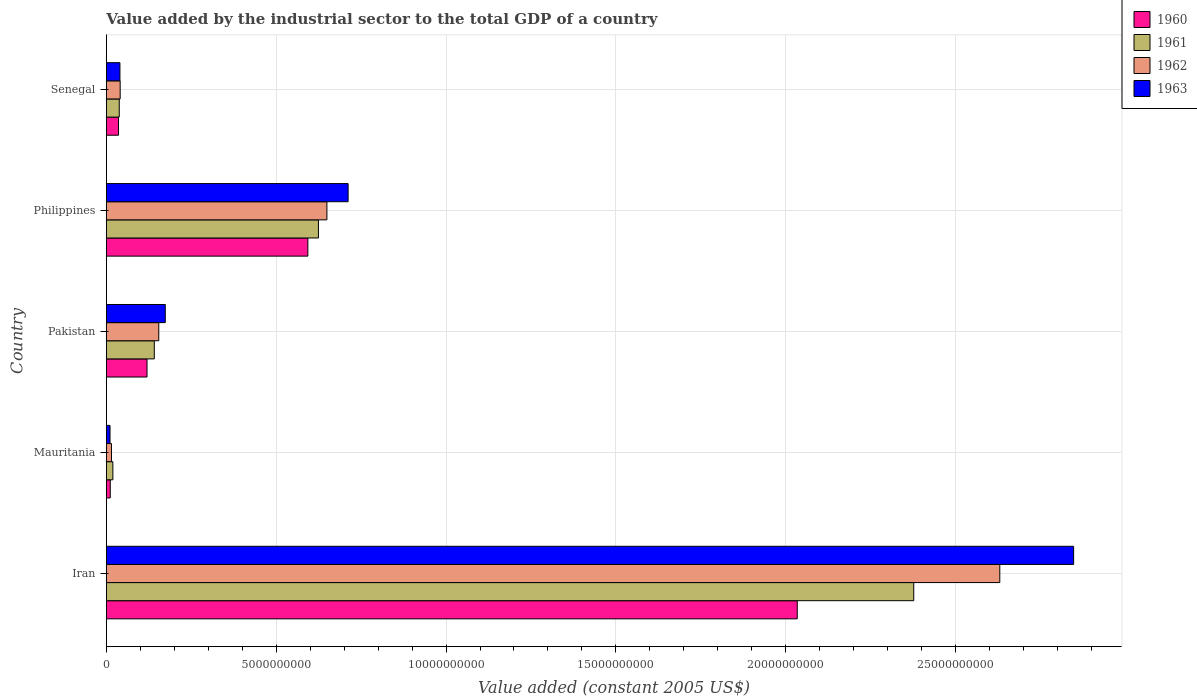How many different coloured bars are there?
Ensure brevity in your answer.  4. How many groups of bars are there?
Provide a succinct answer. 5. How many bars are there on the 1st tick from the top?
Keep it short and to the point. 4. What is the label of the 1st group of bars from the top?
Make the answer very short. Senegal. In how many cases, is the number of bars for a given country not equal to the number of legend labels?
Give a very brief answer. 0. What is the value added by the industrial sector in 1962 in Philippines?
Give a very brief answer. 6.49e+09. Across all countries, what is the maximum value added by the industrial sector in 1961?
Your answer should be compact. 2.38e+1. Across all countries, what is the minimum value added by the industrial sector in 1961?
Ensure brevity in your answer.  1.92e+08. In which country was the value added by the industrial sector in 1962 maximum?
Your answer should be very brief. Iran. In which country was the value added by the industrial sector in 1963 minimum?
Keep it short and to the point. Mauritania. What is the total value added by the industrial sector in 1961 in the graph?
Ensure brevity in your answer.  3.20e+1. What is the difference between the value added by the industrial sector in 1960 in Pakistan and that in Philippines?
Provide a succinct answer. -4.73e+09. What is the difference between the value added by the industrial sector in 1961 in Mauritania and the value added by the industrial sector in 1960 in Senegal?
Make the answer very short. -1.66e+08. What is the average value added by the industrial sector in 1963 per country?
Your answer should be compact. 7.57e+09. What is the difference between the value added by the industrial sector in 1963 and value added by the industrial sector in 1960 in Iran?
Provide a short and direct response. 8.14e+09. What is the ratio of the value added by the industrial sector in 1962 in Iran to that in Philippines?
Make the answer very short. 4.05. What is the difference between the highest and the second highest value added by the industrial sector in 1963?
Offer a terse response. 2.14e+1. What is the difference between the highest and the lowest value added by the industrial sector in 1963?
Provide a short and direct response. 2.84e+1. In how many countries, is the value added by the industrial sector in 1963 greater than the average value added by the industrial sector in 1963 taken over all countries?
Provide a succinct answer. 1. Is the sum of the value added by the industrial sector in 1961 in Pakistan and Senegal greater than the maximum value added by the industrial sector in 1962 across all countries?
Your response must be concise. No. Is it the case that in every country, the sum of the value added by the industrial sector in 1962 and value added by the industrial sector in 1960 is greater than the sum of value added by the industrial sector in 1961 and value added by the industrial sector in 1963?
Offer a terse response. No. Is it the case that in every country, the sum of the value added by the industrial sector in 1963 and value added by the industrial sector in 1962 is greater than the value added by the industrial sector in 1960?
Make the answer very short. Yes. Are all the bars in the graph horizontal?
Keep it short and to the point. Yes. How many countries are there in the graph?
Provide a succinct answer. 5. What is the difference between two consecutive major ticks on the X-axis?
Keep it short and to the point. 5.00e+09. Are the values on the major ticks of X-axis written in scientific E-notation?
Make the answer very short. No. Does the graph contain any zero values?
Ensure brevity in your answer.  No. What is the title of the graph?
Your answer should be compact. Value added by the industrial sector to the total GDP of a country. What is the label or title of the X-axis?
Provide a succinct answer. Value added (constant 2005 US$). What is the Value added (constant 2005 US$) of 1960 in Iran?
Your response must be concise. 2.03e+1. What is the Value added (constant 2005 US$) of 1961 in Iran?
Offer a terse response. 2.38e+1. What is the Value added (constant 2005 US$) in 1962 in Iran?
Your answer should be very brief. 2.63e+1. What is the Value added (constant 2005 US$) of 1963 in Iran?
Offer a terse response. 2.85e+1. What is the Value added (constant 2005 US$) in 1960 in Mauritania?
Your answer should be very brief. 1.15e+08. What is the Value added (constant 2005 US$) in 1961 in Mauritania?
Keep it short and to the point. 1.92e+08. What is the Value added (constant 2005 US$) in 1962 in Mauritania?
Offer a terse response. 1.51e+08. What is the Value added (constant 2005 US$) in 1963 in Mauritania?
Offer a terse response. 1.08e+08. What is the Value added (constant 2005 US$) in 1960 in Pakistan?
Ensure brevity in your answer.  1.20e+09. What is the Value added (constant 2005 US$) of 1961 in Pakistan?
Your answer should be very brief. 1.41e+09. What is the Value added (constant 2005 US$) in 1962 in Pakistan?
Offer a very short reply. 1.54e+09. What is the Value added (constant 2005 US$) of 1963 in Pakistan?
Your answer should be compact. 1.74e+09. What is the Value added (constant 2005 US$) of 1960 in Philippines?
Offer a very short reply. 5.93e+09. What is the Value added (constant 2005 US$) in 1961 in Philippines?
Offer a terse response. 6.24e+09. What is the Value added (constant 2005 US$) of 1962 in Philippines?
Ensure brevity in your answer.  6.49e+09. What is the Value added (constant 2005 US$) of 1963 in Philippines?
Offer a very short reply. 7.12e+09. What is the Value added (constant 2005 US$) of 1960 in Senegal?
Ensure brevity in your answer.  3.58e+08. What is the Value added (constant 2005 US$) in 1961 in Senegal?
Offer a terse response. 3.80e+08. What is the Value added (constant 2005 US$) in 1962 in Senegal?
Provide a short and direct response. 4.08e+08. What is the Value added (constant 2005 US$) in 1963 in Senegal?
Your response must be concise. 4.01e+08. Across all countries, what is the maximum Value added (constant 2005 US$) in 1960?
Provide a succinct answer. 2.03e+1. Across all countries, what is the maximum Value added (constant 2005 US$) of 1961?
Offer a terse response. 2.38e+1. Across all countries, what is the maximum Value added (constant 2005 US$) of 1962?
Provide a short and direct response. 2.63e+1. Across all countries, what is the maximum Value added (constant 2005 US$) in 1963?
Keep it short and to the point. 2.85e+1. Across all countries, what is the minimum Value added (constant 2005 US$) of 1960?
Make the answer very short. 1.15e+08. Across all countries, what is the minimum Value added (constant 2005 US$) in 1961?
Provide a short and direct response. 1.92e+08. Across all countries, what is the minimum Value added (constant 2005 US$) in 1962?
Your answer should be very brief. 1.51e+08. Across all countries, what is the minimum Value added (constant 2005 US$) of 1963?
Ensure brevity in your answer.  1.08e+08. What is the total Value added (constant 2005 US$) in 1960 in the graph?
Keep it short and to the point. 2.79e+1. What is the total Value added (constant 2005 US$) of 1961 in the graph?
Give a very brief answer. 3.20e+1. What is the total Value added (constant 2005 US$) in 1962 in the graph?
Offer a terse response. 3.49e+1. What is the total Value added (constant 2005 US$) in 1963 in the graph?
Provide a short and direct response. 3.78e+1. What is the difference between the Value added (constant 2005 US$) in 1960 in Iran and that in Mauritania?
Keep it short and to the point. 2.02e+1. What is the difference between the Value added (constant 2005 US$) in 1961 in Iran and that in Mauritania?
Provide a succinct answer. 2.36e+1. What is the difference between the Value added (constant 2005 US$) in 1962 in Iran and that in Mauritania?
Give a very brief answer. 2.62e+1. What is the difference between the Value added (constant 2005 US$) in 1963 in Iran and that in Mauritania?
Your answer should be compact. 2.84e+1. What is the difference between the Value added (constant 2005 US$) of 1960 in Iran and that in Pakistan?
Your answer should be very brief. 1.91e+1. What is the difference between the Value added (constant 2005 US$) in 1961 in Iran and that in Pakistan?
Offer a terse response. 2.24e+1. What is the difference between the Value added (constant 2005 US$) in 1962 in Iran and that in Pakistan?
Your answer should be very brief. 2.48e+1. What is the difference between the Value added (constant 2005 US$) of 1963 in Iran and that in Pakistan?
Provide a succinct answer. 2.67e+1. What is the difference between the Value added (constant 2005 US$) in 1960 in Iran and that in Philippines?
Keep it short and to the point. 1.44e+1. What is the difference between the Value added (constant 2005 US$) in 1961 in Iran and that in Philippines?
Your answer should be compact. 1.75e+1. What is the difference between the Value added (constant 2005 US$) in 1962 in Iran and that in Philippines?
Your answer should be compact. 1.98e+1. What is the difference between the Value added (constant 2005 US$) of 1963 in Iran and that in Philippines?
Provide a succinct answer. 2.14e+1. What is the difference between the Value added (constant 2005 US$) in 1960 in Iran and that in Senegal?
Offer a terse response. 2.00e+1. What is the difference between the Value added (constant 2005 US$) in 1961 in Iran and that in Senegal?
Offer a terse response. 2.34e+1. What is the difference between the Value added (constant 2005 US$) of 1962 in Iran and that in Senegal?
Your response must be concise. 2.59e+1. What is the difference between the Value added (constant 2005 US$) of 1963 in Iran and that in Senegal?
Make the answer very short. 2.81e+1. What is the difference between the Value added (constant 2005 US$) in 1960 in Mauritania and that in Pakistan?
Offer a terse response. -1.08e+09. What is the difference between the Value added (constant 2005 US$) in 1961 in Mauritania and that in Pakistan?
Your answer should be compact. -1.22e+09. What is the difference between the Value added (constant 2005 US$) of 1962 in Mauritania and that in Pakistan?
Your response must be concise. -1.39e+09. What is the difference between the Value added (constant 2005 US$) in 1963 in Mauritania and that in Pakistan?
Your answer should be compact. -1.63e+09. What is the difference between the Value added (constant 2005 US$) of 1960 in Mauritania and that in Philippines?
Your answer should be very brief. -5.82e+09. What is the difference between the Value added (constant 2005 US$) of 1961 in Mauritania and that in Philippines?
Your response must be concise. -6.05e+09. What is the difference between the Value added (constant 2005 US$) of 1962 in Mauritania and that in Philippines?
Ensure brevity in your answer.  -6.34e+09. What is the difference between the Value added (constant 2005 US$) of 1963 in Mauritania and that in Philippines?
Your answer should be compact. -7.01e+09. What is the difference between the Value added (constant 2005 US$) in 1960 in Mauritania and that in Senegal?
Provide a short and direct response. -2.42e+08. What is the difference between the Value added (constant 2005 US$) of 1961 in Mauritania and that in Senegal?
Provide a succinct answer. -1.88e+08. What is the difference between the Value added (constant 2005 US$) of 1962 in Mauritania and that in Senegal?
Offer a very short reply. -2.56e+08. What is the difference between the Value added (constant 2005 US$) of 1963 in Mauritania and that in Senegal?
Offer a very short reply. -2.92e+08. What is the difference between the Value added (constant 2005 US$) in 1960 in Pakistan and that in Philippines?
Your answer should be compact. -4.73e+09. What is the difference between the Value added (constant 2005 US$) in 1961 in Pakistan and that in Philippines?
Make the answer very short. -4.83e+09. What is the difference between the Value added (constant 2005 US$) in 1962 in Pakistan and that in Philippines?
Offer a very short reply. -4.95e+09. What is the difference between the Value added (constant 2005 US$) of 1963 in Pakistan and that in Philippines?
Make the answer very short. -5.38e+09. What is the difference between the Value added (constant 2005 US$) in 1960 in Pakistan and that in Senegal?
Your answer should be very brief. 8.40e+08. What is the difference between the Value added (constant 2005 US$) of 1961 in Pakistan and that in Senegal?
Your answer should be compact. 1.03e+09. What is the difference between the Value added (constant 2005 US$) of 1962 in Pakistan and that in Senegal?
Give a very brief answer. 1.14e+09. What is the difference between the Value added (constant 2005 US$) of 1963 in Pakistan and that in Senegal?
Provide a succinct answer. 1.33e+09. What is the difference between the Value added (constant 2005 US$) of 1960 in Philippines and that in Senegal?
Your answer should be compact. 5.57e+09. What is the difference between the Value added (constant 2005 US$) of 1961 in Philippines and that in Senegal?
Give a very brief answer. 5.86e+09. What is the difference between the Value added (constant 2005 US$) in 1962 in Philippines and that in Senegal?
Your answer should be compact. 6.09e+09. What is the difference between the Value added (constant 2005 US$) in 1963 in Philippines and that in Senegal?
Offer a terse response. 6.72e+09. What is the difference between the Value added (constant 2005 US$) of 1960 in Iran and the Value added (constant 2005 US$) of 1961 in Mauritania?
Provide a short and direct response. 2.01e+1. What is the difference between the Value added (constant 2005 US$) in 1960 in Iran and the Value added (constant 2005 US$) in 1962 in Mauritania?
Make the answer very short. 2.02e+1. What is the difference between the Value added (constant 2005 US$) in 1960 in Iran and the Value added (constant 2005 US$) in 1963 in Mauritania?
Keep it short and to the point. 2.02e+1. What is the difference between the Value added (constant 2005 US$) of 1961 in Iran and the Value added (constant 2005 US$) of 1962 in Mauritania?
Your answer should be compact. 2.36e+1. What is the difference between the Value added (constant 2005 US$) of 1961 in Iran and the Value added (constant 2005 US$) of 1963 in Mauritania?
Your answer should be compact. 2.37e+1. What is the difference between the Value added (constant 2005 US$) of 1962 in Iran and the Value added (constant 2005 US$) of 1963 in Mauritania?
Provide a short and direct response. 2.62e+1. What is the difference between the Value added (constant 2005 US$) in 1960 in Iran and the Value added (constant 2005 US$) in 1961 in Pakistan?
Your answer should be compact. 1.89e+1. What is the difference between the Value added (constant 2005 US$) of 1960 in Iran and the Value added (constant 2005 US$) of 1962 in Pakistan?
Your answer should be very brief. 1.88e+1. What is the difference between the Value added (constant 2005 US$) of 1960 in Iran and the Value added (constant 2005 US$) of 1963 in Pakistan?
Keep it short and to the point. 1.86e+1. What is the difference between the Value added (constant 2005 US$) of 1961 in Iran and the Value added (constant 2005 US$) of 1962 in Pakistan?
Your response must be concise. 2.22e+1. What is the difference between the Value added (constant 2005 US$) in 1961 in Iran and the Value added (constant 2005 US$) in 1963 in Pakistan?
Give a very brief answer. 2.20e+1. What is the difference between the Value added (constant 2005 US$) in 1962 in Iran and the Value added (constant 2005 US$) in 1963 in Pakistan?
Give a very brief answer. 2.46e+1. What is the difference between the Value added (constant 2005 US$) in 1960 in Iran and the Value added (constant 2005 US$) in 1961 in Philippines?
Your answer should be compact. 1.41e+1. What is the difference between the Value added (constant 2005 US$) of 1960 in Iran and the Value added (constant 2005 US$) of 1962 in Philippines?
Your answer should be very brief. 1.38e+1. What is the difference between the Value added (constant 2005 US$) of 1960 in Iran and the Value added (constant 2005 US$) of 1963 in Philippines?
Make the answer very short. 1.32e+1. What is the difference between the Value added (constant 2005 US$) of 1961 in Iran and the Value added (constant 2005 US$) of 1962 in Philippines?
Offer a very short reply. 1.73e+1. What is the difference between the Value added (constant 2005 US$) in 1961 in Iran and the Value added (constant 2005 US$) in 1963 in Philippines?
Keep it short and to the point. 1.67e+1. What is the difference between the Value added (constant 2005 US$) of 1962 in Iran and the Value added (constant 2005 US$) of 1963 in Philippines?
Your response must be concise. 1.92e+1. What is the difference between the Value added (constant 2005 US$) in 1960 in Iran and the Value added (constant 2005 US$) in 1961 in Senegal?
Provide a short and direct response. 2.00e+1. What is the difference between the Value added (constant 2005 US$) of 1960 in Iran and the Value added (constant 2005 US$) of 1962 in Senegal?
Give a very brief answer. 1.99e+1. What is the difference between the Value added (constant 2005 US$) in 1960 in Iran and the Value added (constant 2005 US$) in 1963 in Senegal?
Offer a terse response. 1.99e+1. What is the difference between the Value added (constant 2005 US$) of 1961 in Iran and the Value added (constant 2005 US$) of 1962 in Senegal?
Offer a terse response. 2.34e+1. What is the difference between the Value added (constant 2005 US$) of 1961 in Iran and the Value added (constant 2005 US$) of 1963 in Senegal?
Give a very brief answer. 2.34e+1. What is the difference between the Value added (constant 2005 US$) of 1962 in Iran and the Value added (constant 2005 US$) of 1963 in Senegal?
Your answer should be very brief. 2.59e+1. What is the difference between the Value added (constant 2005 US$) of 1960 in Mauritania and the Value added (constant 2005 US$) of 1961 in Pakistan?
Offer a very short reply. -1.30e+09. What is the difference between the Value added (constant 2005 US$) in 1960 in Mauritania and the Value added (constant 2005 US$) in 1962 in Pakistan?
Your answer should be very brief. -1.43e+09. What is the difference between the Value added (constant 2005 US$) in 1960 in Mauritania and the Value added (constant 2005 US$) in 1963 in Pakistan?
Give a very brief answer. -1.62e+09. What is the difference between the Value added (constant 2005 US$) of 1961 in Mauritania and the Value added (constant 2005 US$) of 1962 in Pakistan?
Your response must be concise. -1.35e+09. What is the difference between the Value added (constant 2005 US$) in 1961 in Mauritania and the Value added (constant 2005 US$) in 1963 in Pakistan?
Keep it short and to the point. -1.54e+09. What is the difference between the Value added (constant 2005 US$) in 1962 in Mauritania and the Value added (constant 2005 US$) in 1963 in Pakistan?
Offer a terse response. -1.58e+09. What is the difference between the Value added (constant 2005 US$) of 1960 in Mauritania and the Value added (constant 2005 US$) of 1961 in Philippines?
Give a very brief answer. -6.13e+09. What is the difference between the Value added (constant 2005 US$) of 1960 in Mauritania and the Value added (constant 2005 US$) of 1962 in Philippines?
Give a very brief answer. -6.38e+09. What is the difference between the Value added (constant 2005 US$) of 1960 in Mauritania and the Value added (constant 2005 US$) of 1963 in Philippines?
Ensure brevity in your answer.  -7.00e+09. What is the difference between the Value added (constant 2005 US$) in 1961 in Mauritania and the Value added (constant 2005 US$) in 1962 in Philippines?
Keep it short and to the point. -6.30e+09. What is the difference between the Value added (constant 2005 US$) of 1961 in Mauritania and the Value added (constant 2005 US$) of 1963 in Philippines?
Make the answer very short. -6.93e+09. What is the difference between the Value added (constant 2005 US$) of 1962 in Mauritania and the Value added (constant 2005 US$) of 1963 in Philippines?
Provide a short and direct response. -6.97e+09. What is the difference between the Value added (constant 2005 US$) of 1960 in Mauritania and the Value added (constant 2005 US$) of 1961 in Senegal?
Your response must be concise. -2.65e+08. What is the difference between the Value added (constant 2005 US$) in 1960 in Mauritania and the Value added (constant 2005 US$) in 1962 in Senegal?
Provide a succinct answer. -2.92e+08. What is the difference between the Value added (constant 2005 US$) of 1960 in Mauritania and the Value added (constant 2005 US$) of 1963 in Senegal?
Offer a terse response. -2.85e+08. What is the difference between the Value added (constant 2005 US$) in 1961 in Mauritania and the Value added (constant 2005 US$) in 1962 in Senegal?
Provide a succinct answer. -2.15e+08. What is the difference between the Value added (constant 2005 US$) in 1961 in Mauritania and the Value added (constant 2005 US$) in 1963 in Senegal?
Your answer should be compact. -2.08e+08. What is the difference between the Value added (constant 2005 US$) of 1962 in Mauritania and the Value added (constant 2005 US$) of 1963 in Senegal?
Offer a very short reply. -2.49e+08. What is the difference between the Value added (constant 2005 US$) in 1960 in Pakistan and the Value added (constant 2005 US$) in 1961 in Philippines?
Make the answer very short. -5.05e+09. What is the difference between the Value added (constant 2005 US$) in 1960 in Pakistan and the Value added (constant 2005 US$) in 1962 in Philippines?
Keep it short and to the point. -5.30e+09. What is the difference between the Value added (constant 2005 US$) of 1960 in Pakistan and the Value added (constant 2005 US$) of 1963 in Philippines?
Keep it short and to the point. -5.92e+09. What is the difference between the Value added (constant 2005 US$) of 1961 in Pakistan and the Value added (constant 2005 US$) of 1962 in Philippines?
Your answer should be compact. -5.08e+09. What is the difference between the Value added (constant 2005 US$) in 1961 in Pakistan and the Value added (constant 2005 US$) in 1963 in Philippines?
Give a very brief answer. -5.71e+09. What is the difference between the Value added (constant 2005 US$) in 1962 in Pakistan and the Value added (constant 2005 US$) in 1963 in Philippines?
Provide a succinct answer. -5.57e+09. What is the difference between the Value added (constant 2005 US$) of 1960 in Pakistan and the Value added (constant 2005 US$) of 1961 in Senegal?
Offer a terse response. 8.18e+08. What is the difference between the Value added (constant 2005 US$) in 1960 in Pakistan and the Value added (constant 2005 US$) in 1962 in Senegal?
Give a very brief answer. 7.91e+08. What is the difference between the Value added (constant 2005 US$) in 1960 in Pakistan and the Value added (constant 2005 US$) in 1963 in Senegal?
Your answer should be very brief. 7.98e+08. What is the difference between the Value added (constant 2005 US$) of 1961 in Pakistan and the Value added (constant 2005 US$) of 1962 in Senegal?
Offer a very short reply. 1.00e+09. What is the difference between the Value added (constant 2005 US$) of 1961 in Pakistan and the Value added (constant 2005 US$) of 1963 in Senegal?
Offer a terse response. 1.01e+09. What is the difference between the Value added (constant 2005 US$) in 1962 in Pakistan and the Value added (constant 2005 US$) in 1963 in Senegal?
Keep it short and to the point. 1.14e+09. What is the difference between the Value added (constant 2005 US$) of 1960 in Philippines and the Value added (constant 2005 US$) of 1961 in Senegal?
Your answer should be very brief. 5.55e+09. What is the difference between the Value added (constant 2005 US$) of 1960 in Philippines and the Value added (constant 2005 US$) of 1962 in Senegal?
Offer a terse response. 5.53e+09. What is the difference between the Value added (constant 2005 US$) of 1960 in Philippines and the Value added (constant 2005 US$) of 1963 in Senegal?
Your answer should be very brief. 5.53e+09. What is the difference between the Value added (constant 2005 US$) of 1961 in Philippines and the Value added (constant 2005 US$) of 1962 in Senegal?
Offer a terse response. 5.84e+09. What is the difference between the Value added (constant 2005 US$) in 1961 in Philippines and the Value added (constant 2005 US$) in 1963 in Senegal?
Your answer should be very brief. 5.84e+09. What is the difference between the Value added (constant 2005 US$) in 1962 in Philippines and the Value added (constant 2005 US$) in 1963 in Senegal?
Your answer should be compact. 6.09e+09. What is the average Value added (constant 2005 US$) of 1960 per country?
Offer a very short reply. 5.59e+09. What is the average Value added (constant 2005 US$) in 1961 per country?
Keep it short and to the point. 6.40e+09. What is the average Value added (constant 2005 US$) in 1962 per country?
Keep it short and to the point. 6.98e+09. What is the average Value added (constant 2005 US$) in 1963 per country?
Offer a terse response. 7.57e+09. What is the difference between the Value added (constant 2005 US$) of 1960 and Value added (constant 2005 US$) of 1961 in Iran?
Provide a short and direct response. -3.43e+09. What is the difference between the Value added (constant 2005 US$) of 1960 and Value added (constant 2005 US$) of 1962 in Iran?
Make the answer very short. -5.96e+09. What is the difference between the Value added (constant 2005 US$) of 1960 and Value added (constant 2005 US$) of 1963 in Iran?
Ensure brevity in your answer.  -8.14e+09. What is the difference between the Value added (constant 2005 US$) of 1961 and Value added (constant 2005 US$) of 1962 in Iran?
Offer a terse response. -2.53e+09. What is the difference between the Value added (constant 2005 US$) in 1961 and Value added (constant 2005 US$) in 1963 in Iran?
Provide a short and direct response. -4.71e+09. What is the difference between the Value added (constant 2005 US$) of 1962 and Value added (constant 2005 US$) of 1963 in Iran?
Offer a very short reply. -2.17e+09. What is the difference between the Value added (constant 2005 US$) in 1960 and Value added (constant 2005 US$) in 1961 in Mauritania?
Offer a terse response. -7.68e+07. What is the difference between the Value added (constant 2005 US$) of 1960 and Value added (constant 2005 US$) of 1962 in Mauritania?
Your response must be concise. -3.59e+07. What is the difference between the Value added (constant 2005 US$) in 1960 and Value added (constant 2005 US$) in 1963 in Mauritania?
Provide a succinct answer. 7.13e+06. What is the difference between the Value added (constant 2005 US$) of 1961 and Value added (constant 2005 US$) of 1962 in Mauritania?
Keep it short and to the point. 4.09e+07. What is the difference between the Value added (constant 2005 US$) in 1961 and Value added (constant 2005 US$) in 1963 in Mauritania?
Ensure brevity in your answer.  8.39e+07. What is the difference between the Value added (constant 2005 US$) in 1962 and Value added (constant 2005 US$) in 1963 in Mauritania?
Your answer should be compact. 4.31e+07. What is the difference between the Value added (constant 2005 US$) of 1960 and Value added (constant 2005 US$) of 1961 in Pakistan?
Offer a terse response. -2.14e+08. What is the difference between the Value added (constant 2005 US$) of 1960 and Value added (constant 2005 US$) of 1962 in Pakistan?
Your answer should be compact. -3.45e+08. What is the difference between the Value added (constant 2005 US$) in 1960 and Value added (constant 2005 US$) in 1963 in Pakistan?
Your answer should be compact. -5.37e+08. What is the difference between the Value added (constant 2005 US$) of 1961 and Value added (constant 2005 US$) of 1962 in Pakistan?
Your response must be concise. -1.32e+08. What is the difference between the Value added (constant 2005 US$) in 1961 and Value added (constant 2005 US$) in 1963 in Pakistan?
Offer a terse response. -3.23e+08. What is the difference between the Value added (constant 2005 US$) in 1962 and Value added (constant 2005 US$) in 1963 in Pakistan?
Keep it short and to the point. -1.92e+08. What is the difference between the Value added (constant 2005 US$) in 1960 and Value added (constant 2005 US$) in 1961 in Philippines?
Provide a succinct answer. -3.11e+08. What is the difference between the Value added (constant 2005 US$) of 1960 and Value added (constant 2005 US$) of 1962 in Philippines?
Your answer should be very brief. -5.61e+08. What is the difference between the Value added (constant 2005 US$) of 1960 and Value added (constant 2005 US$) of 1963 in Philippines?
Offer a very short reply. -1.18e+09. What is the difference between the Value added (constant 2005 US$) in 1961 and Value added (constant 2005 US$) in 1962 in Philippines?
Your response must be concise. -2.50e+08. What is the difference between the Value added (constant 2005 US$) of 1961 and Value added (constant 2005 US$) of 1963 in Philippines?
Your response must be concise. -8.74e+08. What is the difference between the Value added (constant 2005 US$) of 1962 and Value added (constant 2005 US$) of 1963 in Philippines?
Your response must be concise. -6.24e+08. What is the difference between the Value added (constant 2005 US$) of 1960 and Value added (constant 2005 US$) of 1961 in Senegal?
Your answer should be very brief. -2.25e+07. What is the difference between the Value added (constant 2005 US$) in 1960 and Value added (constant 2005 US$) in 1962 in Senegal?
Ensure brevity in your answer.  -4.98e+07. What is the difference between the Value added (constant 2005 US$) in 1960 and Value added (constant 2005 US$) in 1963 in Senegal?
Your answer should be compact. -4.27e+07. What is the difference between the Value added (constant 2005 US$) in 1961 and Value added (constant 2005 US$) in 1962 in Senegal?
Provide a succinct answer. -2.72e+07. What is the difference between the Value added (constant 2005 US$) in 1961 and Value added (constant 2005 US$) in 1963 in Senegal?
Your answer should be very brief. -2.02e+07. What is the difference between the Value added (constant 2005 US$) of 1962 and Value added (constant 2005 US$) of 1963 in Senegal?
Provide a succinct answer. 7.03e+06. What is the ratio of the Value added (constant 2005 US$) of 1960 in Iran to that in Mauritania?
Keep it short and to the point. 176.32. What is the ratio of the Value added (constant 2005 US$) of 1961 in Iran to that in Mauritania?
Offer a very short reply. 123.7. What is the ratio of the Value added (constant 2005 US$) in 1962 in Iran to that in Mauritania?
Make the answer very short. 173.84. What is the ratio of the Value added (constant 2005 US$) in 1963 in Iran to that in Mauritania?
Offer a terse response. 263.11. What is the ratio of the Value added (constant 2005 US$) of 1960 in Iran to that in Pakistan?
Your answer should be very brief. 16.98. What is the ratio of the Value added (constant 2005 US$) in 1961 in Iran to that in Pakistan?
Give a very brief answer. 16.84. What is the ratio of the Value added (constant 2005 US$) of 1962 in Iran to that in Pakistan?
Make the answer very short. 17.04. What is the ratio of the Value added (constant 2005 US$) of 1963 in Iran to that in Pakistan?
Your response must be concise. 16.41. What is the ratio of the Value added (constant 2005 US$) of 1960 in Iran to that in Philippines?
Your answer should be very brief. 3.43. What is the ratio of the Value added (constant 2005 US$) in 1961 in Iran to that in Philippines?
Make the answer very short. 3.81. What is the ratio of the Value added (constant 2005 US$) in 1962 in Iran to that in Philippines?
Your answer should be compact. 4.05. What is the ratio of the Value added (constant 2005 US$) in 1963 in Iran to that in Philippines?
Offer a terse response. 4. What is the ratio of the Value added (constant 2005 US$) in 1960 in Iran to that in Senegal?
Your response must be concise. 56.85. What is the ratio of the Value added (constant 2005 US$) of 1961 in Iran to that in Senegal?
Provide a succinct answer. 62.5. What is the ratio of the Value added (constant 2005 US$) of 1962 in Iran to that in Senegal?
Your answer should be compact. 64.54. What is the ratio of the Value added (constant 2005 US$) in 1963 in Iran to that in Senegal?
Your answer should be very brief. 71.1. What is the ratio of the Value added (constant 2005 US$) in 1960 in Mauritania to that in Pakistan?
Make the answer very short. 0.1. What is the ratio of the Value added (constant 2005 US$) in 1961 in Mauritania to that in Pakistan?
Provide a short and direct response. 0.14. What is the ratio of the Value added (constant 2005 US$) in 1962 in Mauritania to that in Pakistan?
Offer a terse response. 0.1. What is the ratio of the Value added (constant 2005 US$) in 1963 in Mauritania to that in Pakistan?
Your response must be concise. 0.06. What is the ratio of the Value added (constant 2005 US$) of 1960 in Mauritania to that in Philippines?
Offer a terse response. 0.02. What is the ratio of the Value added (constant 2005 US$) in 1961 in Mauritania to that in Philippines?
Your answer should be compact. 0.03. What is the ratio of the Value added (constant 2005 US$) in 1962 in Mauritania to that in Philippines?
Keep it short and to the point. 0.02. What is the ratio of the Value added (constant 2005 US$) of 1963 in Mauritania to that in Philippines?
Your response must be concise. 0.02. What is the ratio of the Value added (constant 2005 US$) in 1960 in Mauritania to that in Senegal?
Your answer should be very brief. 0.32. What is the ratio of the Value added (constant 2005 US$) in 1961 in Mauritania to that in Senegal?
Offer a very short reply. 0.51. What is the ratio of the Value added (constant 2005 US$) of 1962 in Mauritania to that in Senegal?
Give a very brief answer. 0.37. What is the ratio of the Value added (constant 2005 US$) in 1963 in Mauritania to that in Senegal?
Your answer should be compact. 0.27. What is the ratio of the Value added (constant 2005 US$) in 1960 in Pakistan to that in Philippines?
Your response must be concise. 0.2. What is the ratio of the Value added (constant 2005 US$) of 1961 in Pakistan to that in Philippines?
Your answer should be compact. 0.23. What is the ratio of the Value added (constant 2005 US$) in 1962 in Pakistan to that in Philippines?
Your response must be concise. 0.24. What is the ratio of the Value added (constant 2005 US$) in 1963 in Pakistan to that in Philippines?
Offer a very short reply. 0.24. What is the ratio of the Value added (constant 2005 US$) in 1960 in Pakistan to that in Senegal?
Make the answer very short. 3.35. What is the ratio of the Value added (constant 2005 US$) of 1961 in Pakistan to that in Senegal?
Offer a terse response. 3.71. What is the ratio of the Value added (constant 2005 US$) of 1962 in Pakistan to that in Senegal?
Your answer should be compact. 3.79. What is the ratio of the Value added (constant 2005 US$) of 1963 in Pakistan to that in Senegal?
Your response must be concise. 4.33. What is the ratio of the Value added (constant 2005 US$) in 1960 in Philippines to that in Senegal?
Your answer should be very brief. 16.58. What is the ratio of the Value added (constant 2005 US$) in 1961 in Philippines to that in Senegal?
Provide a succinct answer. 16.42. What is the ratio of the Value added (constant 2005 US$) in 1962 in Philippines to that in Senegal?
Your answer should be compact. 15.93. What is the ratio of the Value added (constant 2005 US$) of 1963 in Philippines to that in Senegal?
Your answer should be compact. 17.77. What is the difference between the highest and the second highest Value added (constant 2005 US$) of 1960?
Offer a terse response. 1.44e+1. What is the difference between the highest and the second highest Value added (constant 2005 US$) of 1961?
Your response must be concise. 1.75e+1. What is the difference between the highest and the second highest Value added (constant 2005 US$) of 1962?
Give a very brief answer. 1.98e+1. What is the difference between the highest and the second highest Value added (constant 2005 US$) in 1963?
Make the answer very short. 2.14e+1. What is the difference between the highest and the lowest Value added (constant 2005 US$) in 1960?
Your answer should be very brief. 2.02e+1. What is the difference between the highest and the lowest Value added (constant 2005 US$) in 1961?
Offer a terse response. 2.36e+1. What is the difference between the highest and the lowest Value added (constant 2005 US$) of 1962?
Provide a succinct answer. 2.62e+1. What is the difference between the highest and the lowest Value added (constant 2005 US$) of 1963?
Offer a terse response. 2.84e+1. 